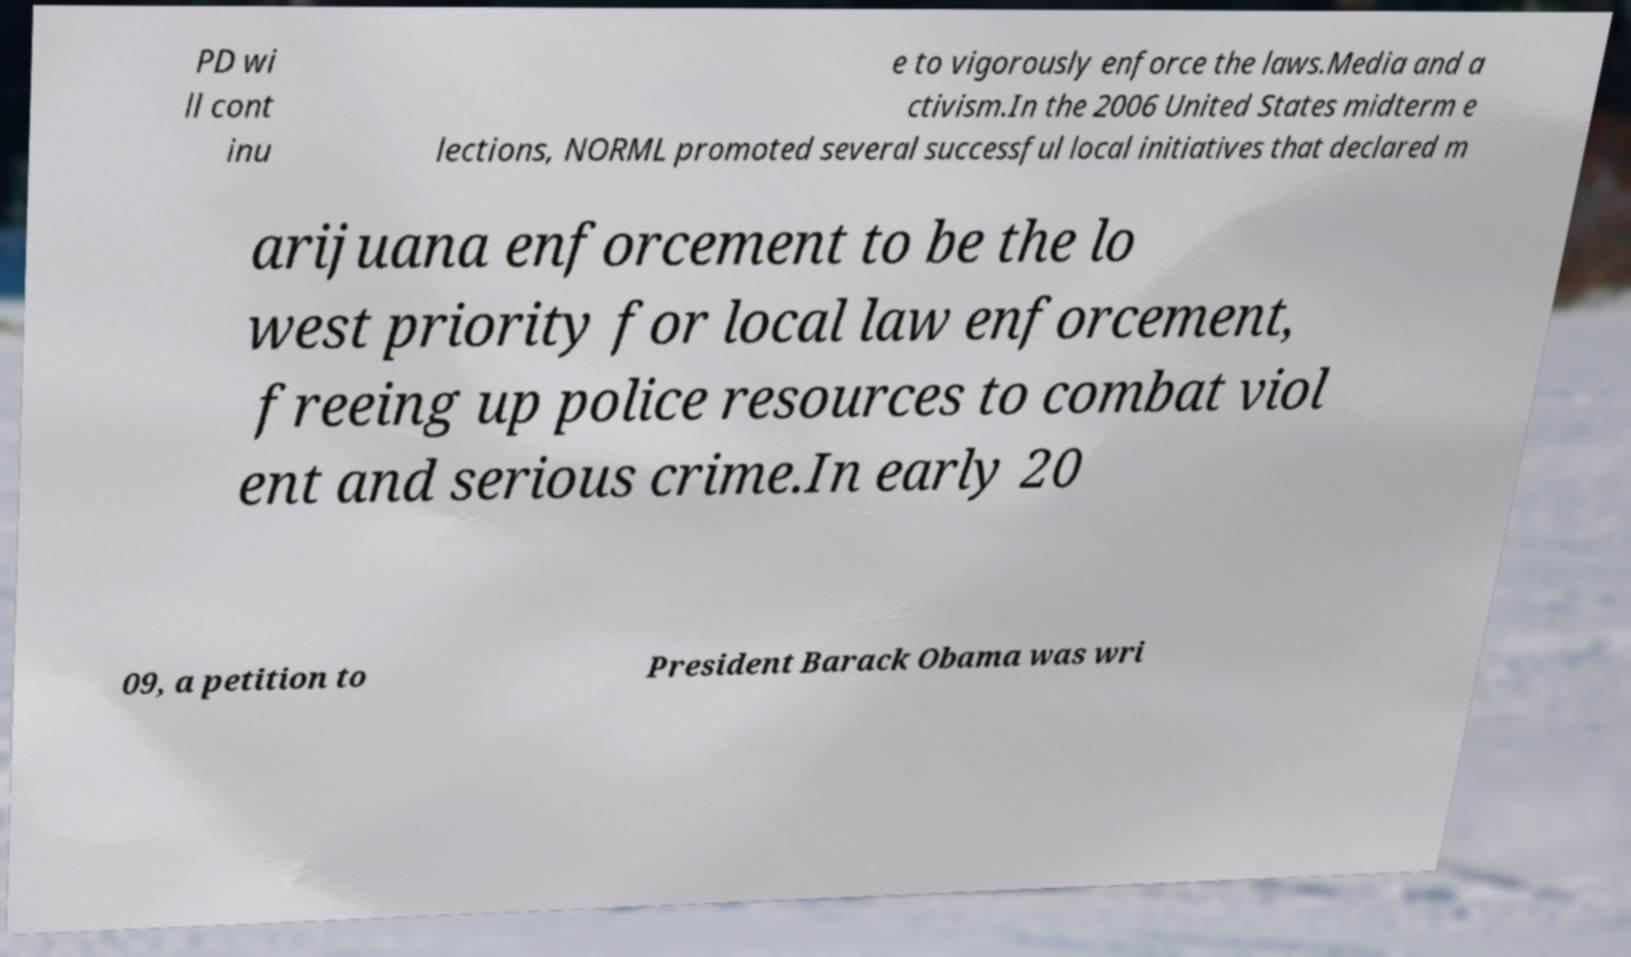Can you accurately transcribe the text from the provided image for me? PD wi ll cont inu e to vigorously enforce the laws.Media and a ctivism.In the 2006 United States midterm e lections, NORML promoted several successful local initiatives that declared m arijuana enforcement to be the lo west priority for local law enforcement, freeing up police resources to combat viol ent and serious crime.In early 20 09, a petition to President Barack Obama was wri 